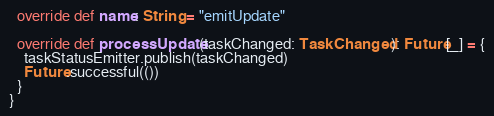Convert code to text. <code><loc_0><loc_0><loc_500><loc_500><_Scala_>
  override def name: String = "emitUpdate"

  override def processUpdate(taskChanged: TaskChanged): Future[_] = {
    taskStatusEmitter.publish(taskChanged)
    Future.successful(())
  }
}
</code> 